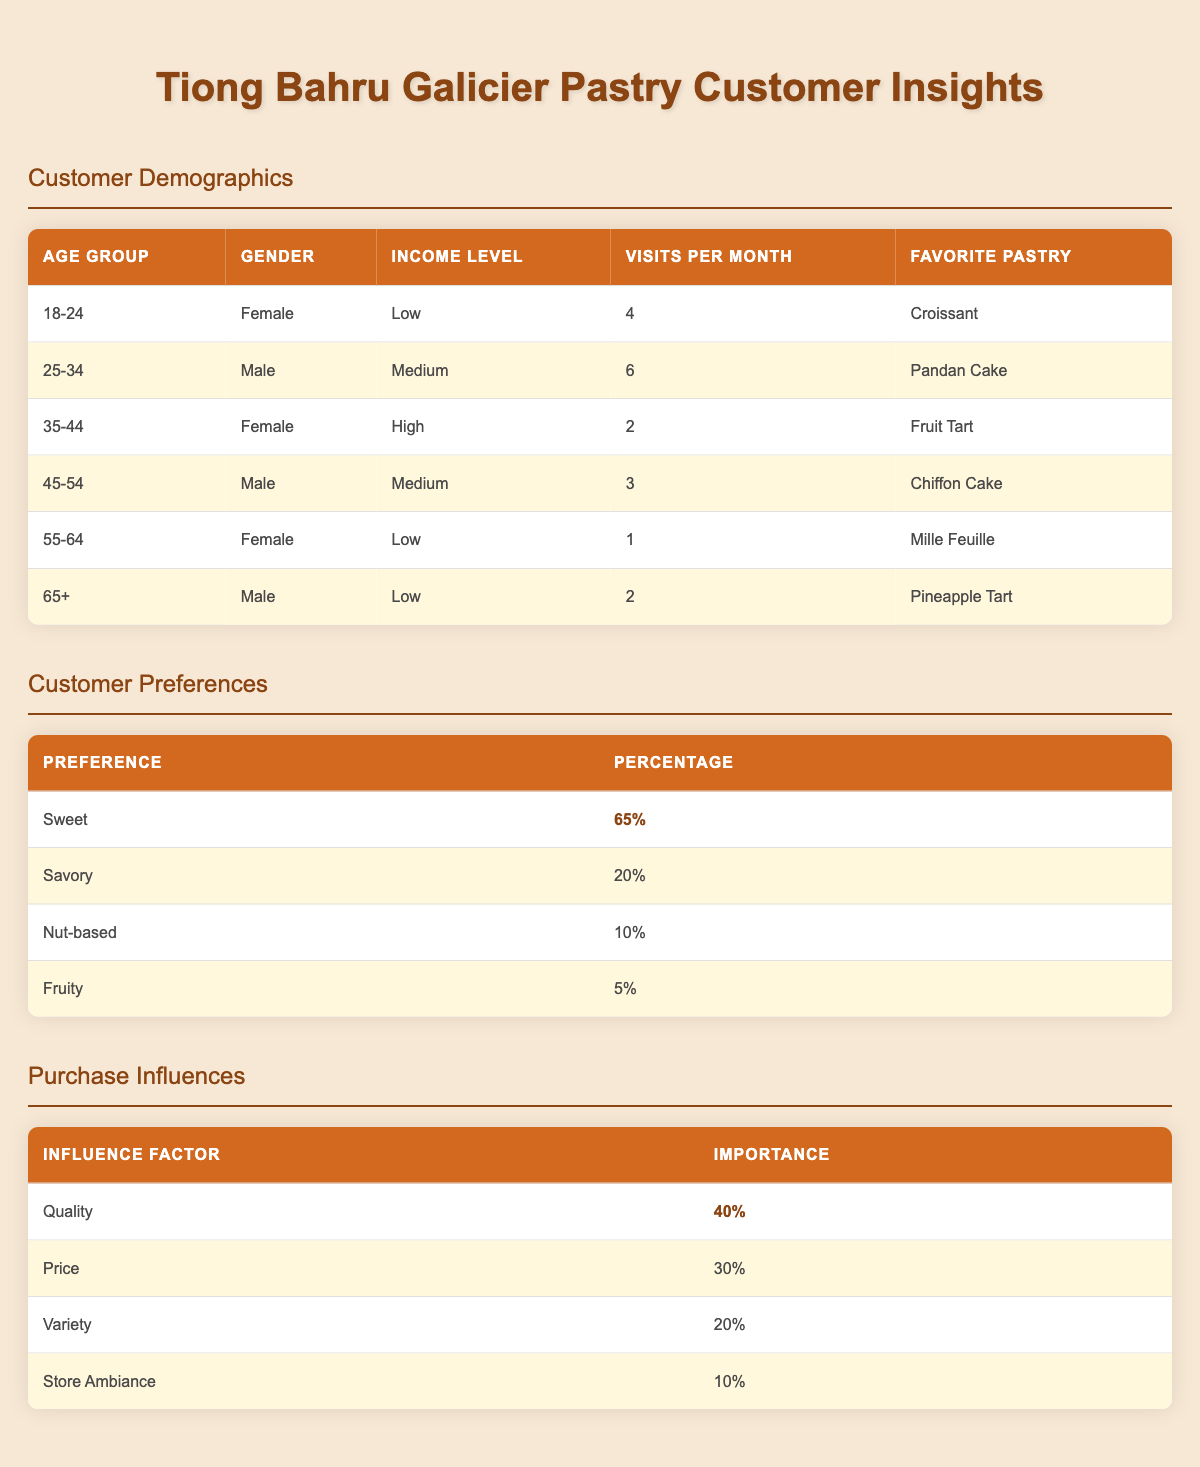What is the favorite pastry of the 25-34 age group? In the customer demographics table, I look under the "age_group" column for 25-34. In that row, the "favorite_pastry" column indicates the favorite pastry as "Pandan Cake."
Answer: Pandan Cake How many males are in the 45-54 age group who visit the pastry shop? In the customer demographics table, I count the number of males under the 45-54 age group. There is one entry for this age group, and the gender is Male.
Answer: 1 What is the average number of visits per month for female customers? I look at female customers’ visits. There are three female customers with visits per month of 4, 2, and 1. Summing these visits gives 4 + 2 + 1 = 7. There are three female customers, so I divide by 3: 7/3 = 2.33.
Answer: 2.33 Is the majority of customers in Tiong Bahru preferring sweet pastries? I check the customer preferences table, where "Sweet" is 65%. This is clearly higher than half, as 50% would indicate a majority. Therefore, yes, the majority prefer sweet pastries.
Answer: Yes Which age group has the highest visits per month? I review the visits per month in the customer demographics table. The entries show 4, 6, 2, 3, 1, and 2 for the respective age groups. The highest is 6, corresponding to the 25-34 age group.
Answer: 25-34 